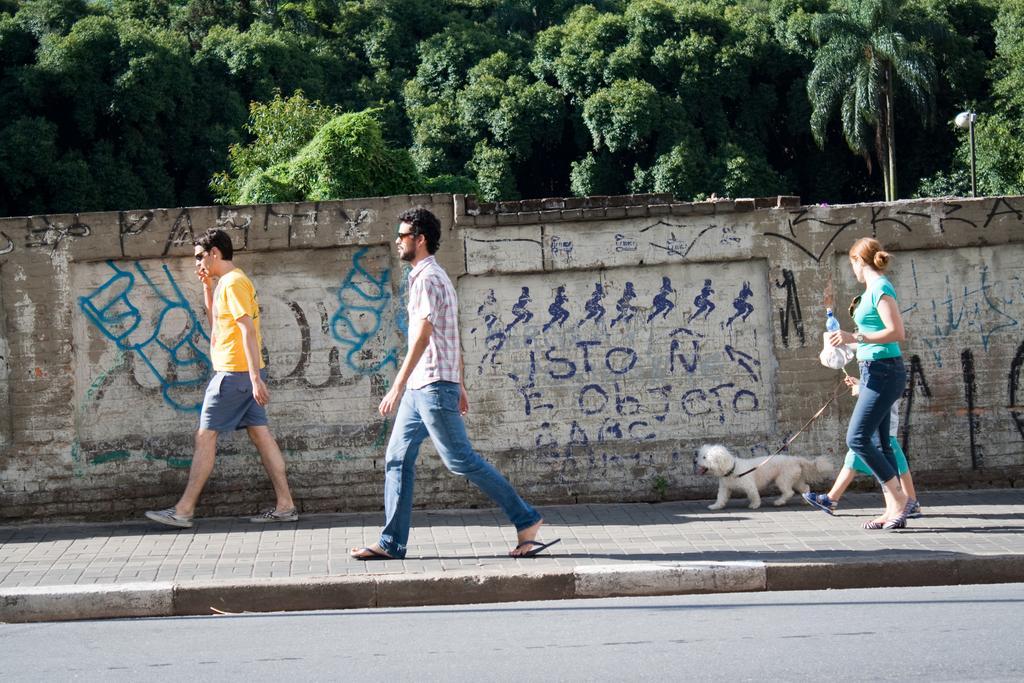Could you give a brief overview of what you see in this image? This image is taken outdoors. At the bottom of the image there is a road and there is a sidewalk. In the background there are many trees and there is a wall with a few paintings and a text on it. In the middle of the image two men are walking on the sidewalk. On the right side of the image a woman, a kid and a dog are walking on the sidewalk. A woman is holding a bottle in her hand. 